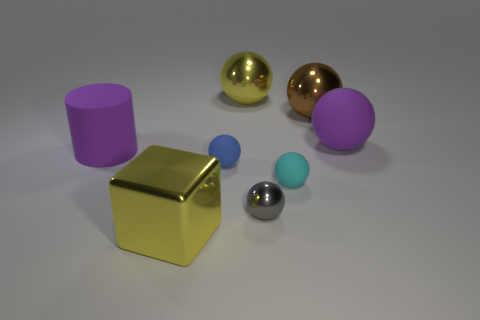What material is the cyan ball that is the same size as the blue rubber thing?
Ensure brevity in your answer.  Rubber. What is the big yellow thing on the right side of the big yellow thing in front of the big purple cylinder made of?
Provide a succinct answer. Metal. There is a brown shiny object that is right of the yellow metal ball; is it the same shape as the small cyan rubber thing?
Your answer should be compact. Yes. What is the color of the large object that is the same material as the large purple cylinder?
Keep it short and to the point. Purple. There is a yellow thing that is behind the large matte cylinder; what is its material?
Give a very brief answer. Metal. Do the brown object and the yellow shiny thing that is to the right of the big yellow metal cube have the same shape?
Provide a succinct answer. Yes. What is the material of the thing that is behind the gray metallic object and in front of the tiny blue matte ball?
Your answer should be compact. Rubber. The other matte thing that is the same size as the cyan rubber object is what color?
Your answer should be compact. Blue. Do the brown sphere and the large thing in front of the tiny cyan thing have the same material?
Offer a terse response. Yes. How many other objects are there of the same size as the gray sphere?
Ensure brevity in your answer.  2. 